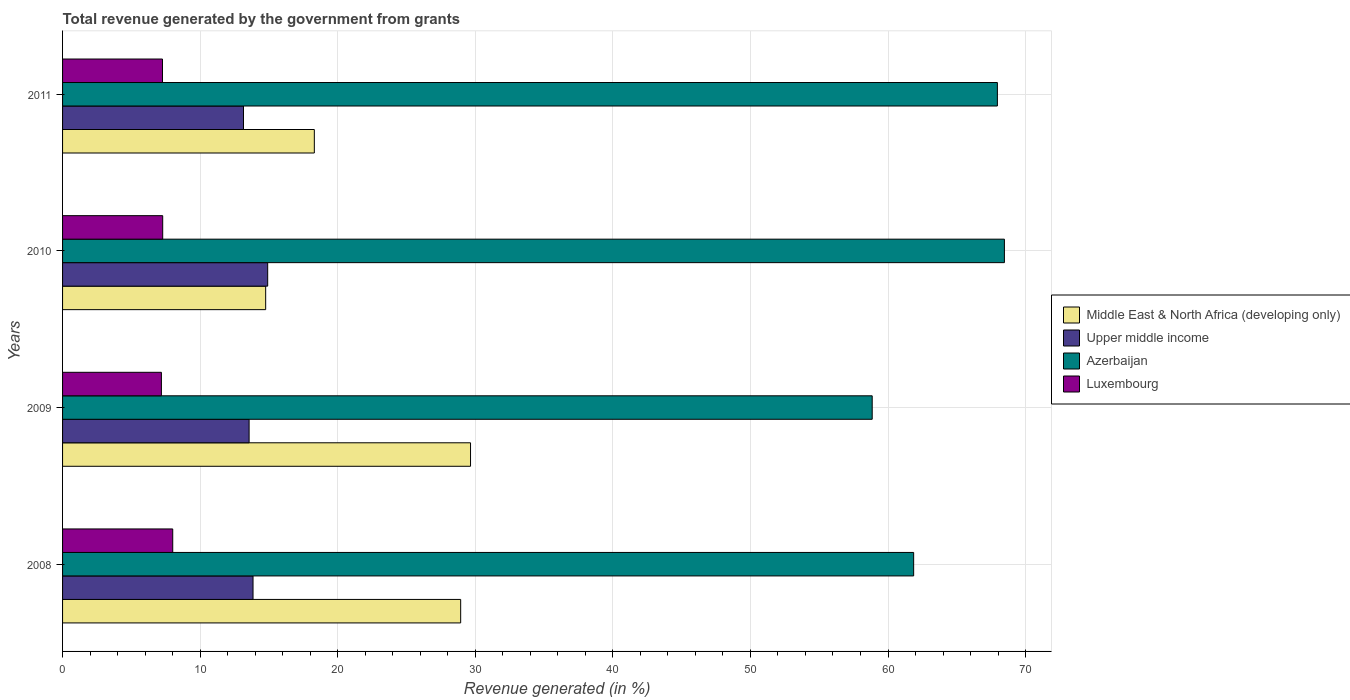In how many cases, is the number of bars for a given year not equal to the number of legend labels?
Your response must be concise. 0. What is the total revenue generated in Middle East & North Africa (developing only) in 2011?
Provide a succinct answer. 18.3. Across all years, what is the maximum total revenue generated in Azerbaijan?
Give a very brief answer. 68.46. Across all years, what is the minimum total revenue generated in Middle East & North Africa (developing only)?
Make the answer very short. 14.76. In which year was the total revenue generated in Upper middle income maximum?
Your answer should be very brief. 2010. In which year was the total revenue generated in Upper middle income minimum?
Keep it short and to the point. 2011. What is the total total revenue generated in Upper middle income in the graph?
Give a very brief answer. 55.47. What is the difference between the total revenue generated in Luxembourg in 2008 and that in 2010?
Your answer should be compact. 0.73. What is the difference between the total revenue generated in Upper middle income in 2009 and the total revenue generated in Azerbaijan in 2011?
Give a very brief answer. -54.39. What is the average total revenue generated in Azerbaijan per year?
Your response must be concise. 64.28. In the year 2009, what is the difference between the total revenue generated in Middle East & North Africa (developing only) and total revenue generated in Azerbaijan?
Provide a short and direct response. -29.2. What is the ratio of the total revenue generated in Azerbaijan in 2009 to that in 2010?
Offer a very short reply. 0.86. Is the total revenue generated in Luxembourg in 2008 less than that in 2010?
Ensure brevity in your answer.  No. What is the difference between the highest and the second highest total revenue generated in Luxembourg?
Your response must be concise. 0.73. What is the difference between the highest and the lowest total revenue generated in Upper middle income?
Ensure brevity in your answer.  1.76. Is the sum of the total revenue generated in Azerbaijan in 2008 and 2011 greater than the maximum total revenue generated in Middle East & North Africa (developing only) across all years?
Keep it short and to the point. Yes. Is it the case that in every year, the sum of the total revenue generated in Upper middle income and total revenue generated in Azerbaijan is greater than the sum of total revenue generated in Middle East & North Africa (developing only) and total revenue generated in Luxembourg?
Offer a very short reply. No. What does the 1st bar from the top in 2009 represents?
Your answer should be compact. Luxembourg. What does the 4th bar from the bottom in 2008 represents?
Your response must be concise. Luxembourg. Is it the case that in every year, the sum of the total revenue generated in Middle East & North Africa (developing only) and total revenue generated in Luxembourg is greater than the total revenue generated in Azerbaijan?
Provide a short and direct response. No. How many years are there in the graph?
Make the answer very short. 4. What is the difference between two consecutive major ticks on the X-axis?
Offer a very short reply. 10. Does the graph contain any zero values?
Offer a very short reply. No. Where does the legend appear in the graph?
Offer a terse response. Center right. What is the title of the graph?
Give a very brief answer. Total revenue generated by the government from grants. Does "Middle East & North Africa (all income levels)" appear as one of the legend labels in the graph?
Offer a terse response. No. What is the label or title of the X-axis?
Offer a terse response. Revenue generated (in %). What is the label or title of the Y-axis?
Ensure brevity in your answer.  Years. What is the Revenue generated (in %) in Middle East & North Africa (developing only) in 2008?
Keep it short and to the point. 28.94. What is the Revenue generated (in %) of Upper middle income in 2008?
Your answer should be very brief. 13.84. What is the Revenue generated (in %) in Azerbaijan in 2008?
Offer a terse response. 61.87. What is the Revenue generated (in %) in Luxembourg in 2008?
Offer a very short reply. 8.01. What is the Revenue generated (in %) in Middle East & North Africa (developing only) in 2009?
Provide a succinct answer. 29.65. What is the Revenue generated (in %) of Upper middle income in 2009?
Give a very brief answer. 13.56. What is the Revenue generated (in %) in Azerbaijan in 2009?
Make the answer very short. 58.85. What is the Revenue generated (in %) of Luxembourg in 2009?
Make the answer very short. 7.19. What is the Revenue generated (in %) of Middle East & North Africa (developing only) in 2010?
Offer a very short reply. 14.76. What is the Revenue generated (in %) of Upper middle income in 2010?
Give a very brief answer. 14.91. What is the Revenue generated (in %) in Azerbaijan in 2010?
Provide a succinct answer. 68.46. What is the Revenue generated (in %) in Luxembourg in 2010?
Your answer should be compact. 7.28. What is the Revenue generated (in %) in Middle East & North Africa (developing only) in 2011?
Give a very brief answer. 18.3. What is the Revenue generated (in %) of Upper middle income in 2011?
Make the answer very short. 13.15. What is the Revenue generated (in %) in Azerbaijan in 2011?
Offer a very short reply. 67.95. What is the Revenue generated (in %) in Luxembourg in 2011?
Give a very brief answer. 7.26. Across all years, what is the maximum Revenue generated (in %) of Middle East & North Africa (developing only)?
Your answer should be very brief. 29.65. Across all years, what is the maximum Revenue generated (in %) in Upper middle income?
Make the answer very short. 14.91. Across all years, what is the maximum Revenue generated (in %) of Azerbaijan?
Your answer should be compact. 68.46. Across all years, what is the maximum Revenue generated (in %) in Luxembourg?
Offer a very short reply. 8.01. Across all years, what is the minimum Revenue generated (in %) in Middle East & North Africa (developing only)?
Provide a succinct answer. 14.76. Across all years, what is the minimum Revenue generated (in %) of Upper middle income?
Make the answer very short. 13.15. Across all years, what is the minimum Revenue generated (in %) of Azerbaijan?
Your answer should be very brief. 58.85. Across all years, what is the minimum Revenue generated (in %) of Luxembourg?
Provide a short and direct response. 7.19. What is the total Revenue generated (in %) of Middle East & North Africa (developing only) in the graph?
Ensure brevity in your answer.  91.66. What is the total Revenue generated (in %) of Upper middle income in the graph?
Keep it short and to the point. 55.47. What is the total Revenue generated (in %) of Azerbaijan in the graph?
Provide a short and direct response. 257.13. What is the total Revenue generated (in %) in Luxembourg in the graph?
Give a very brief answer. 29.74. What is the difference between the Revenue generated (in %) of Middle East & North Africa (developing only) in 2008 and that in 2009?
Your answer should be very brief. -0.72. What is the difference between the Revenue generated (in %) of Upper middle income in 2008 and that in 2009?
Your answer should be compact. 0.28. What is the difference between the Revenue generated (in %) of Azerbaijan in 2008 and that in 2009?
Ensure brevity in your answer.  3.01. What is the difference between the Revenue generated (in %) in Luxembourg in 2008 and that in 2009?
Offer a very short reply. 0.82. What is the difference between the Revenue generated (in %) of Middle East & North Africa (developing only) in 2008 and that in 2010?
Provide a succinct answer. 14.17. What is the difference between the Revenue generated (in %) in Upper middle income in 2008 and that in 2010?
Your answer should be very brief. -1.07. What is the difference between the Revenue generated (in %) of Azerbaijan in 2008 and that in 2010?
Make the answer very short. -6.6. What is the difference between the Revenue generated (in %) of Luxembourg in 2008 and that in 2010?
Keep it short and to the point. 0.73. What is the difference between the Revenue generated (in %) in Middle East & North Africa (developing only) in 2008 and that in 2011?
Give a very brief answer. 10.64. What is the difference between the Revenue generated (in %) in Upper middle income in 2008 and that in 2011?
Provide a succinct answer. 0.69. What is the difference between the Revenue generated (in %) of Azerbaijan in 2008 and that in 2011?
Offer a very short reply. -6.09. What is the difference between the Revenue generated (in %) in Luxembourg in 2008 and that in 2011?
Keep it short and to the point. 0.75. What is the difference between the Revenue generated (in %) of Middle East & North Africa (developing only) in 2009 and that in 2010?
Make the answer very short. 14.89. What is the difference between the Revenue generated (in %) of Upper middle income in 2009 and that in 2010?
Your answer should be compact. -1.35. What is the difference between the Revenue generated (in %) in Azerbaijan in 2009 and that in 2010?
Provide a succinct answer. -9.61. What is the difference between the Revenue generated (in %) of Luxembourg in 2009 and that in 2010?
Offer a very short reply. -0.09. What is the difference between the Revenue generated (in %) in Middle East & North Africa (developing only) in 2009 and that in 2011?
Your answer should be compact. 11.35. What is the difference between the Revenue generated (in %) in Upper middle income in 2009 and that in 2011?
Provide a short and direct response. 0.41. What is the difference between the Revenue generated (in %) of Azerbaijan in 2009 and that in 2011?
Your answer should be compact. -9.1. What is the difference between the Revenue generated (in %) in Luxembourg in 2009 and that in 2011?
Your answer should be compact. -0.08. What is the difference between the Revenue generated (in %) in Middle East & North Africa (developing only) in 2010 and that in 2011?
Keep it short and to the point. -3.54. What is the difference between the Revenue generated (in %) in Upper middle income in 2010 and that in 2011?
Your response must be concise. 1.76. What is the difference between the Revenue generated (in %) of Azerbaijan in 2010 and that in 2011?
Give a very brief answer. 0.51. What is the difference between the Revenue generated (in %) in Luxembourg in 2010 and that in 2011?
Provide a short and direct response. 0.02. What is the difference between the Revenue generated (in %) in Middle East & North Africa (developing only) in 2008 and the Revenue generated (in %) in Upper middle income in 2009?
Your response must be concise. 15.38. What is the difference between the Revenue generated (in %) in Middle East & North Africa (developing only) in 2008 and the Revenue generated (in %) in Azerbaijan in 2009?
Keep it short and to the point. -29.91. What is the difference between the Revenue generated (in %) of Middle East & North Africa (developing only) in 2008 and the Revenue generated (in %) of Luxembourg in 2009?
Ensure brevity in your answer.  21.75. What is the difference between the Revenue generated (in %) in Upper middle income in 2008 and the Revenue generated (in %) in Azerbaijan in 2009?
Offer a very short reply. -45.01. What is the difference between the Revenue generated (in %) of Upper middle income in 2008 and the Revenue generated (in %) of Luxembourg in 2009?
Your answer should be compact. 6.66. What is the difference between the Revenue generated (in %) in Azerbaijan in 2008 and the Revenue generated (in %) in Luxembourg in 2009?
Provide a short and direct response. 54.68. What is the difference between the Revenue generated (in %) of Middle East & North Africa (developing only) in 2008 and the Revenue generated (in %) of Upper middle income in 2010?
Offer a terse response. 14.03. What is the difference between the Revenue generated (in %) of Middle East & North Africa (developing only) in 2008 and the Revenue generated (in %) of Azerbaijan in 2010?
Offer a very short reply. -39.52. What is the difference between the Revenue generated (in %) of Middle East & North Africa (developing only) in 2008 and the Revenue generated (in %) of Luxembourg in 2010?
Give a very brief answer. 21.66. What is the difference between the Revenue generated (in %) in Upper middle income in 2008 and the Revenue generated (in %) in Azerbaijan in 2010?
Give a very brief answer. -54.62. What is the difference between the Revenue generated (in %) of Upper middle income in 2008 and the Revenue generated (in %) of Luxembourg in 2010?
Provide a short and direct response. 6.57. What is the difference between the Revenue generated (in %) in Azerbaijan in 2008 and the Revenue generated (in %) in Luxembourg in 2010?
Make the answer very short. 54.59. What is the difference between the Revenue generated (in %) of Middle East & North Africa (developing only) in 2008 and the Revenue generated (in %) of Upper middle income in 2011?
Provide a short and direct response. 15.79. What is the difference between the Revenue generated (in %) of Middle East & North Africa (developing only) in 2008 and the Revenue generated (in %) of Azerbaijan in 2011?
Give a very brief answer. -39.01. What is the difference between the Revenue generated (in %) in Middle East & North Africa (developing only) in 2008 and the Revenue generated (in %) in Luxembourg in 2011?
Your response must be concise. 21.67. What is the difference between the Revenue generated (in %) of Upper middle income in 2008 and the Revenue generated (in %) of Azerbaijan in 2011?
Your answer should be compact. -54.11. What is the difference between the Revenue generated (in %) of Upper middle income in 2008 and the Revenue generated (in %) of Luxembourg in 2011?
Your answer should be very brief. 6.58. What is the difference between the Revenue generated (in %) in Azerbaijan in 2008 and the Revenue generated (in %) in Luxembourg in 2011?
Ensure brevity in your answer.  54.6. What is the difference between the Revenue generated (in %) in Middle East & North Africa (developing only) in 2009 and the Revenue generated (in %) in Upper middle income in 2010?
Offer a terse response. 14.74. What is the difference between the Revenue generated (in %) in Middle East & North Africa (developing only) in 2009 and the Revenue generated (in %) in Azerbaijan in 2010?
Give a very brief answer. -38.81. What is the difference between the Revenue generated (in %) of Middle East & North Africa (developing only) in 2009 and the Revenue generated (in %) of Luxembourg in 2010?
Offer a very short reply. 22.38. What is the difference between the Revenue generated (in %) of Upper middle income in 2009 and the Revenue generated (in %) of Azerbaijan in 2010?
Offer a very short reply. -54.9. What is the difference between the Revenue generated (in %) of Upper middle income in 2009 and the Revenue generated (in %) of Luxembourg in 2010?
Your answer should be very brief. 6.28. What is the difference between the Revenue generated (in %) of Azerbaijan in 2009 and the Revenue generated (in %) of Luxembourg in 2010?
Offer a very short reply. 51.57. What is the difference between the Revenue generated (in %) of Middle East & North Africa (developing only) in 2009 and the Revenue generated (in %) of Upper middle income in 2011?
Your answer should be compact. 16.5. What is the difference between the Revenue generated (in %) in Middle East & North Africa (developing only) in 2009 and the Revenue generated (in %) in Azerbaijan in 2011?
Offer a terse response. -38.3. What is the difference between the Revenue generated (in %) of Middle East & North Africa (developing only) in 2009 and the Revenue generated (in %) of Luxembourg in 2011?
Keep it short and to the point. 22.39. What is the difference between the Revenue generated (in %) in Upper middle income in 2009 and the Revenue generated (in %) in Azerbaijan in 2011?
Provide a short and direct response. -54.39. What is the difference between the Revenue generated (in %) in Upper middle income in 2009 and the Revenue generated (in %) in Luxembourg in 2011?
Give a very brief answer. 6.3. What is the difference between the Revenue generated (in %) in Azerbaijan in 2009 and the Revenue generated (in %) in Luxembourg in 2011?
Provide a short and direct response. 51.59. What is the difference between the Revenue generated (in %) of Middle East & North Africa (developing only) in 2010 and the Revenue generated (in %) of Upper middle income in 2011?
Provide a short and direct response. 1.61. What is the difference between the Revenue generated (in %) in Middle East & North Africa (developing only) in 2010 and the Revenue generated (in %) in Azerbaijan in 2011?
Your answer should be very brief. -53.19. What is the difference between the Revenue generated (in %) in Middle East & North Africa (developing only) in 2010 and the Revenue generated (in %) in Luxembourg in 2011?
Your answer should be very brief. 7.5. What is the difference between the Revenue generated (in %) in Upper middle income in 2010 and the Revenue generated (in %) in Azerbaijan in 2011?
Ensure brevity in your answer.  -53.04. What is the difference between the Revenue generated (in %) in Upper middle income in 2010 and the Revenue generated (in %) in Luxembourg in 2011?
Make the answer very short. 7.65. What is the difference between the Revenue generated (in %) in Azerbaijan in 2010 and the Revenue generated (in %) in Luxembourg in 2011?
Provide a short and direct response. 61.2. What is the average Revenue generated (in %) of Middle East & North Africa (developing only) per year?
Offer a terse response. 22.91. What is the average Revenue generated (in %) in Upper middle income per year?
Provide a succinct answer. 13.87. What is the average Revenue generated (in %) in Azerbaijan per year?
Provide a short and direct response. 64.28. What is the average Revenue generated (in %) in Luxembourg per year?
Provide a short and direct response. 7.43. In the year 2008, what is the difference between the Revenue generated (in %) of Middle East & North Africa (developing only) and Revenue generated (in %) of Upper middle income?
Offer a terse response. 15.09. In the year 2008, what is the difference between the Revenue generated (in %) of Middle East & North Africa (developing only) and Revenue generated (in %) of Azerbaijan?
Ensure brevity in your answer.  -32.93. In the year 2008, what is the difference between the Revenue generated (in %) in Middle East & North Africa (developing only) and Revenue generated (in %) in Luxembourg?
Provide a succinct answer. 20.93. In the year 2008, what is the difference between the Revenue generated (in %) of Upper middle income and Revenue generated (in %) of Azerbaijan?
Make the answer very short. -48.02. In the year 2008, what is the difference between the Revenue generated (in %) in Upper middle income and Revenue generated (in %) in Luxembourg?
Your response must be concise. 5.84. In the year 2008, what is the difference between the Revenue generated (in %) of Azerbaijan and Revenue generated (in %) of Luxembourg?
Keep it short and to the point. 53.86. In the year 2009, what is the difference between the Revenue generated (in %) of Middle East & North Africa (developing only) and Revenue generated (in %) of Upper middle income?
Your answer should be very brief. 16.09. In the year 2009, what is the difference between the Revenue generated (in %) in Middle East & North Africa (developing only) and Revenue generated (in %) in Azerbaijan?
Provide a short and direct response. -29.2. In the year 2009, what is the difference between the Revenue generated (in %) of Middle East & North Africa (developing only) and Revenue generated (in %) of Luxembourg?
Your answer should be very brief. 22.47. In the year 2009, what is the difference between the Revenue generated (in %) of Upper middle income and Revenue generated (in %) of Azerbaijan?
Ensure brevity in your answer.  -45.29. In the year 2009, what is the difference between the Revenue generated (in %) in Upper middle income and Revenue generated (in %) in Luxembourg?
Your answer should be compact. 6.37. In the year 2009, what is the difference between the Revenue generated (in %) of Azerbaijan and Revenue generated (in %) of Luxembourg?
Make the answer very short. 51.67. In the year 2010, what is the difference between the Revenue generated (in %) in Middle East & North Africa (developing only) and Revenue generated (in %) in Upper middle income?
Your answer should be compact. -0.15. In the year 2010, what is the difference between the Revenue generated (in %) of Middle East & North Africa (developing only) and Revenue generated (in %) of Azerbaijan?
Your response must be concise. -53.7. In the year 2010, what is the difference between the Revenue generated (in %) of Middle East & North Africa (developing only) and Revenue generated (in %) of Luxembourg?
Ensure brevity in your answer.  7.49. In the year 2010, what is the difference between the Revenue generated (in %) of Upper middle income and Revenue generated (in %) of Azerbaijan?
Provide a succinct answer. -53.55. In the year 2010, what is the difference between the Revenue generated (in %) in Upper middle income and Revenue generated (in %) in Luxembourg?
Your answer should be compact. 7.63. In the year 2010, what is the difference between the Revenue generated (in %) of Azerbaijan and Revenue generated (in %) of Luxembourg?
Your answer should be compact. 61.18. In the year 2011, what is the difference between the Revenue generated (in %) of Middle East & North Africa (developing only) and Revenue generated (in %) of Upper middle income?
Make the answer very short. 5.15. In the year 2011, what is the difference between the Revenue generated (in %) of Middle East & North Africa (developing only) and Revenue generated (in %) of Azerbaijan?
Provide a short and direct response. -49.65. In the year 2011, what is the difference between the Revenue generated (in %) in Middle East & North Africa (developing only) and Revenue generated (in %) in Luxembourg?
Your response must be concise. 11.04. In the year 2011, what is the difference between the Revenue generated (in %) of Upper middle income and Revenue generated (in %) of Azerbaijan?
Provide a short and direct response. -54.8. In the year 2011, what is the difference between the Revenue generated (in %) of Upper middle income and Revenue generated (in %) of Luxembourg?
Keep it short and to the point. 5.89. In the year 2011, what is the difference between the Revenue generated (in %) of Azerbaijan and Revenue generated (in %) of Luxembourg?
Offer a terse response. 60.69. What is the ratio of the Revenue generated (in %) in Middle East & North Africa (developing only) in 2008 to that in 2009?
Provide a succinct answer. 0.98. What is the ratio of the Revenue generated (in %) of Azerbaijan in 2008 to that in 2009?
Your answer should be compact. 1.05. What is the ratio of the Revenue generated (in %) in Luxembourg in 2008 to that in 2009?
Provide a short and direct response. 1.11. What is the ratio of the Revenue generated (in %) in Middle East & North Africa (developing only) in 2008 to that in 2010?
Ensure brevity in your answer.  1.96. What is the ratio of the Revenue generated (in %) of Upper middle income in 2008 to that in 2010?
Your response must be concise. 0.93. What is the ratio of the Revenue generated (in %) of Azerbaijan in 2008 to that in 2010?
Offer a very short reply. 0.9. What is the ratio of the Revenue generated (in %) of Luxembourg in 2008 to that in 2010?
Make the answer very short. 1.1. What is the ratio of the Revenue generated (in %) of Middle East & North Africa (developing only) in 2008 to that in 2011?
Your answer should be very brief. 1.58. What is the ratio of the Revenue generated (in %) of Upper middle income in 2008 to that in 2011?
Give a very brief answer. 1.05. What is the ratio of the Revenue generated (in %) of Azerbaijan in 2008 to that in 2011?
Provide a short and direct response. 0.91. What is the ratio of the Revenue generated (in %) in Luxembourg in 2008 to that in 2011?
Provide a short and direct response. 1.1. What is the ratio of the Revenue generated (in %) in Middle East & North Africa (developing only) in 2009 to that in 2010?
Your response must be concise. 2.01. What is the ratio of the Revenue generated (in %) in Upper middle income in 2009 to that in 2010?
Make the answer very short. 0.91. What is the ratio of the Revenue generated (in %) of Azerbaijan in 2009 to that in 2010?
Keep it short and to the point. 0.86. What is the ratio of the Revenue generated (in %) of Luxembourg in 2009 to that in 2010?
Ensure brevity in your answer.  0.99. What is the ratio of the Revenue generated (in %) of Middle East & North Africa (developing only) in 2009 to that in 2011?
Provide a short and direct response. 1.62. What is the ratio of the Revenue generated (in %) in Upper middle income in 2009 to that in 2011?
Your answer should be compact. 1.03. What is the ratio of the Revenue generated (in %) of Azerbaijan in 2009 to that in 2011?
Keep it short and to the point. 0.87. What is the ratio of the Revenue generated (in %) in Luxembourg in 2009 to that in 2011?
Keep it short and to the point. 0.99. What is the ratio of the Revenue generated (in %) in Middle East & North Africa (developing only) in 2010 to that in 2011?
Make the answer very short. 0.81. What is the ratio of the Revenue generated (in %) in Upper middle income in 2010 to that in 2011?
Provide a succinct answer. 1.13. What is the ratio of the Revenue generated (in %) in Azerbaijan in 2010 to that in 2011?
Your answer should be compact. 1.01. What is the difference between the highest and the second highest Revenue generated (in %) in Middle East & North Africa (developing only)?
Give a very brief answer. 0.72. What is the difference between the highest and the second highest Revenue generated (in %) of Upper middle income?
Ensure brevity in your answer.  1.07. What is the difference between the highest and the second highest Revenue generated (in %) in Azerbaijan?
Your response must be concise. 0.51. What is the difference between the highest and the second highest Revenue generated (in %) of Luxembourg?
Ensure brevity in your answer.  0.73. What is the difference between the highest and the lowest Revenue generated (in %) in Middle East & North Africa (developing only)?
Offer a terse response. 14.89. What is the difference between the highest and the lowest Revenue generated (in %) in Upper middle income?
Keep it short and to the point. 1.76. What is the difference between the highest and the lowest Revenue generated (in %) in Azerbaijan?
Make the answer very short. 9.61. What is the difference between the highest and the lowest Revenue generated (in %) in Luxembourg?
Your answer should be compact. 0.82. 